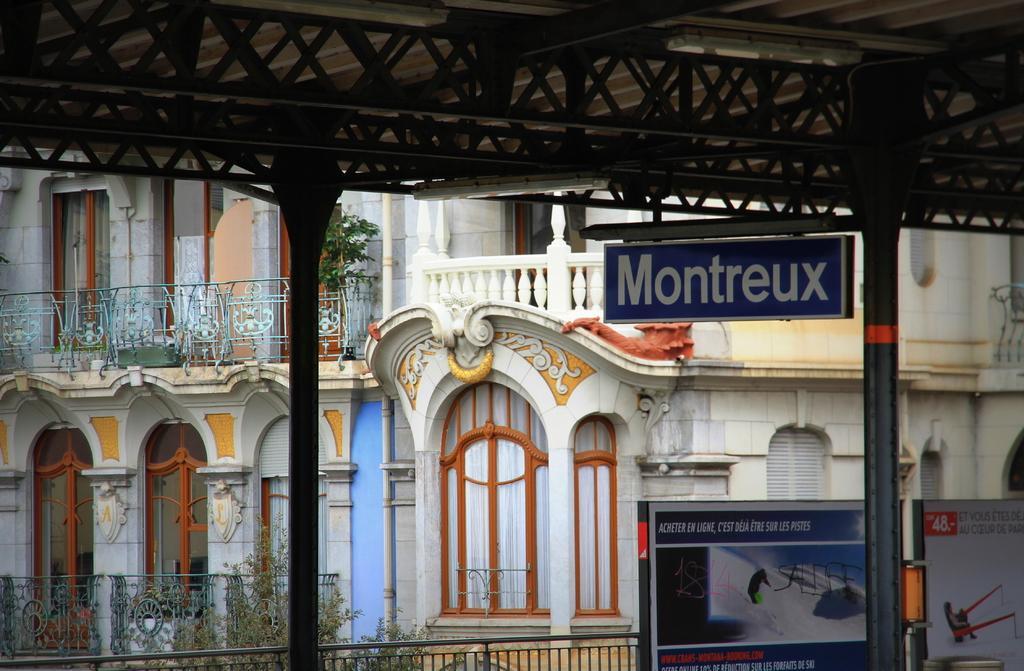In one or two sentences, can you explain what this image depicts? In this image, in the middle there are sign boards, pole, text. In the background there are buildings, plants, railing, pole, windows, roof. 